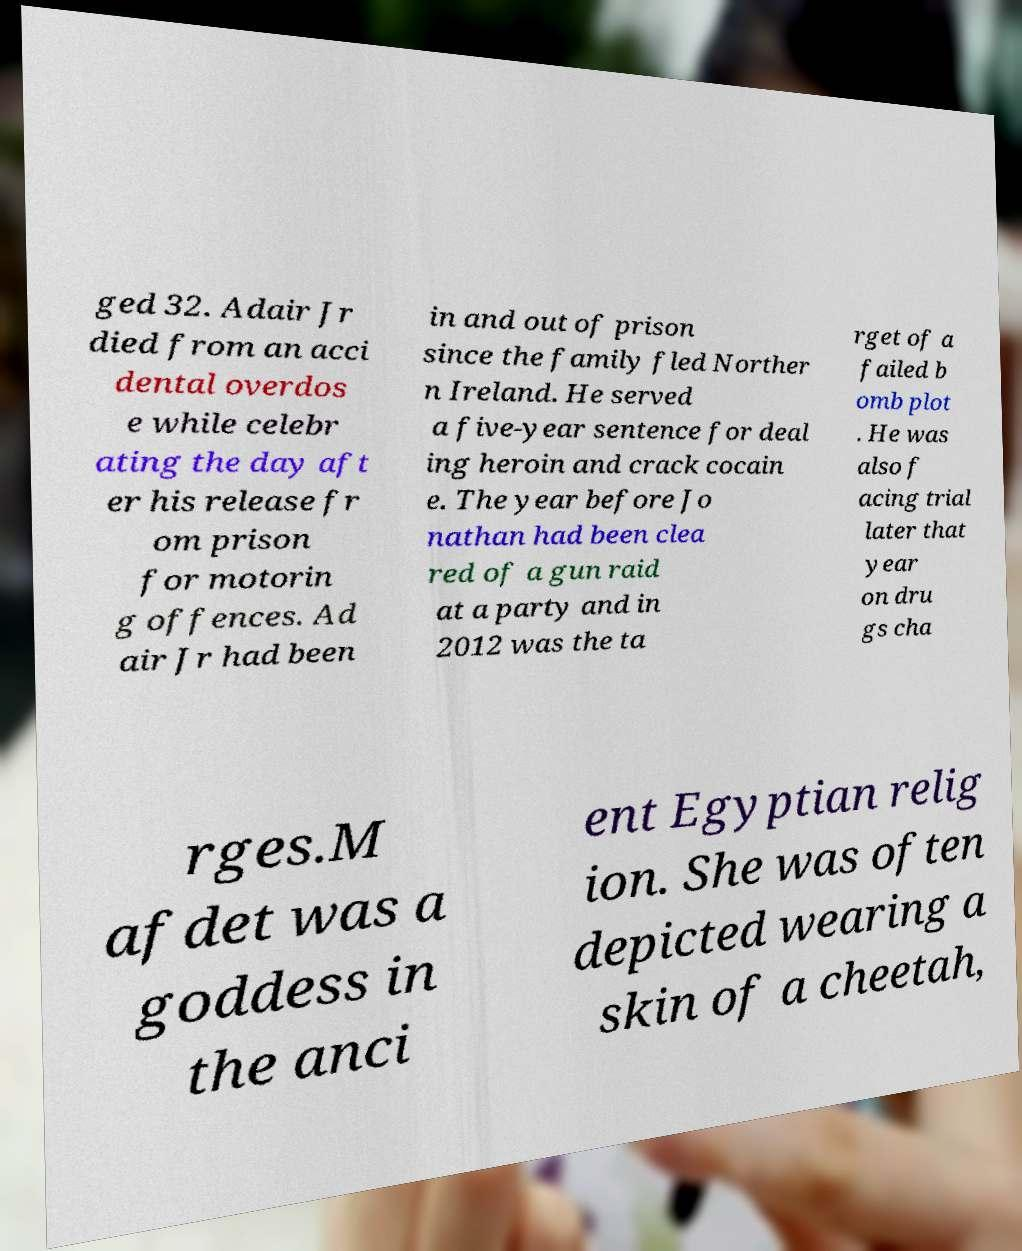I need the written content from this picture converted into text. Can you do that? ged 32. Adair Jr died from an acci dental overdos e while celebr ating the day aft er his release fr om prison for motorin g offences. Ad air Jr had been in and out of prison since the family fled Norther n Ireland. He served a five-year sentence for deal ing heroin and crack cocain e. The year before Jo nathan had been clea red of a gun raid at a party and in 2012 was the ta rget of a failed b omb plot . He was also f acing trial later that year on dru gs cha rges.M afdet was a goddess in the anci ent Egyptian relig ion. She was often depicted wearing a skin of a cheetah, 